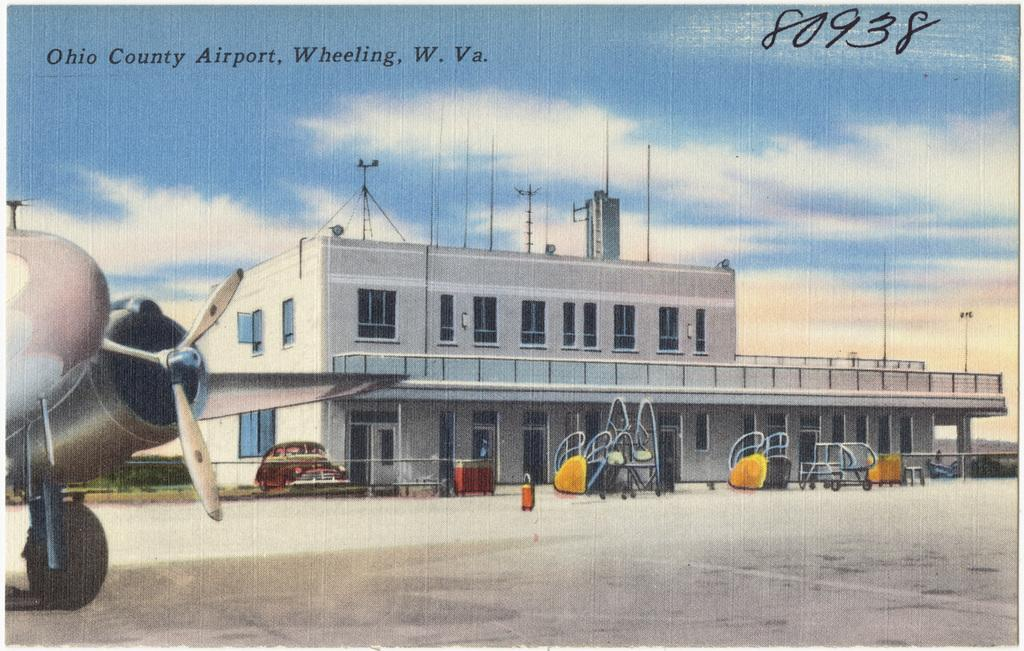What is present in the image that contains visual and written information? There is a poster in the image that contains images and text. Can you describe the images on the poster? The provided facts do not give specific details about the images on the poster. What type of information is conveyed through the text on the poster? The provided facts do not give specific details about the text on the poster. What color are the trousers worn by the ducks on the bridge in the image? There are no trousers, ducks, or bridge present in the image; it only contains a poster with images and text. 